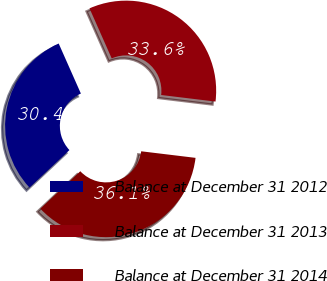Convert chart to OTSL. <chart><loc_0><loc_0><loc_500><loc_500><pie_chart><fcel>Balance at December 31 2012<fcel>Balance at December 31 2013<fcel>Balance at December 31 2014<nl><fcel>30.35%<fcel>33.56%<fcel>36.09%<nl></chart> 